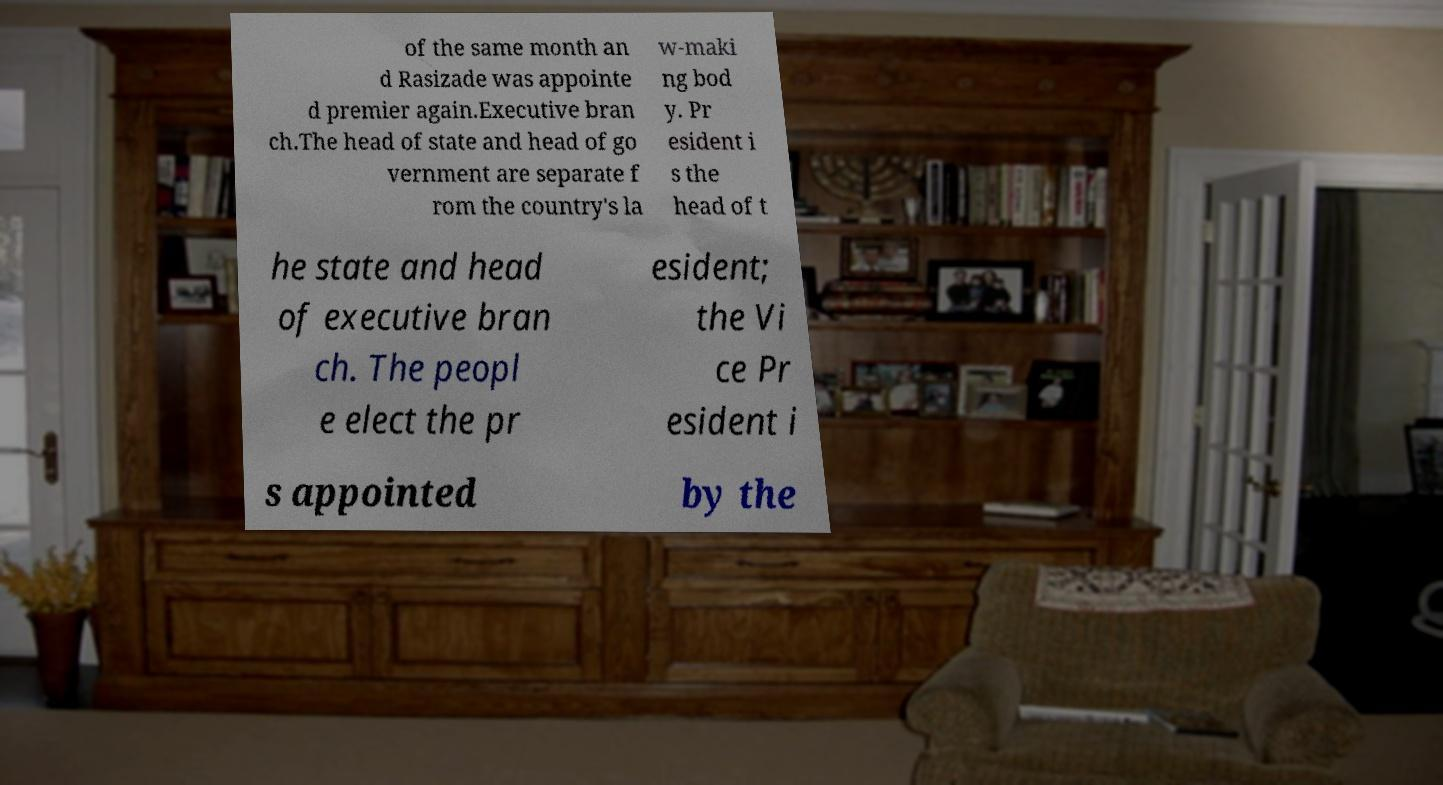Can you accurately transcribe the text from the provided image for me? of the same month an d Rasizade was appointe d premier again.Executive bran ch.The head of state and head of go vernment are separate f rom the country's la w-maki ng bod y. Pr esident i s the head of t he state and head of executive bran ch. The peopl e elect the pr esident; the Vi ce Pr esident i s appointed by the 